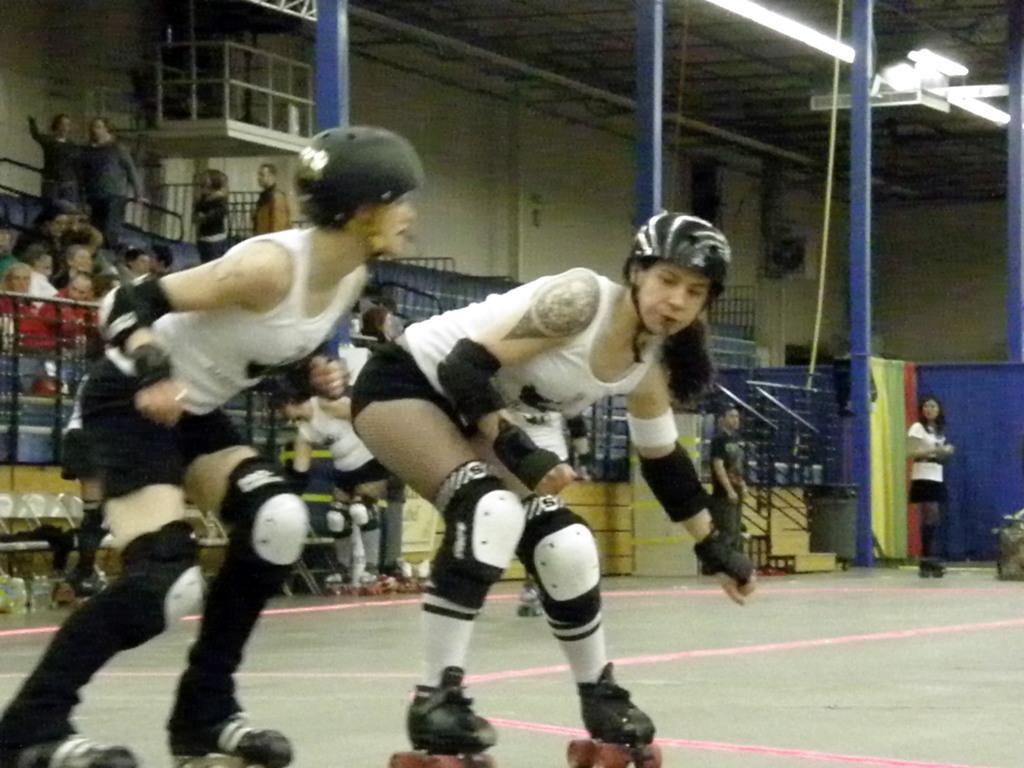Please provide a concise description of this image. In the center of the image we can see two persons are skating and they are wearing helmets. In the background there is a building, poles, lights, fences, one rope, few people are sitting, few people are standing and few other objects. 